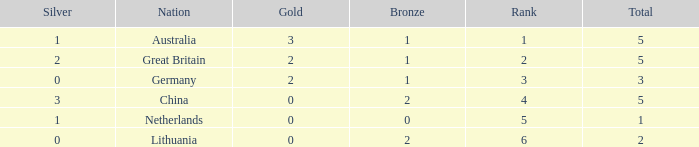What is the average Gold when the rank is less than 3 and the bronze is less than 1? None. 